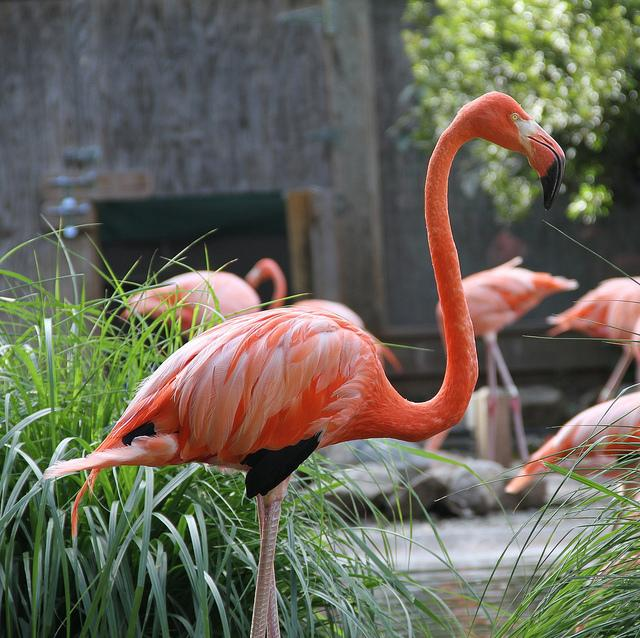How many birds are in focus?

Choices:
A) four
B) two
C) one
D) three one 